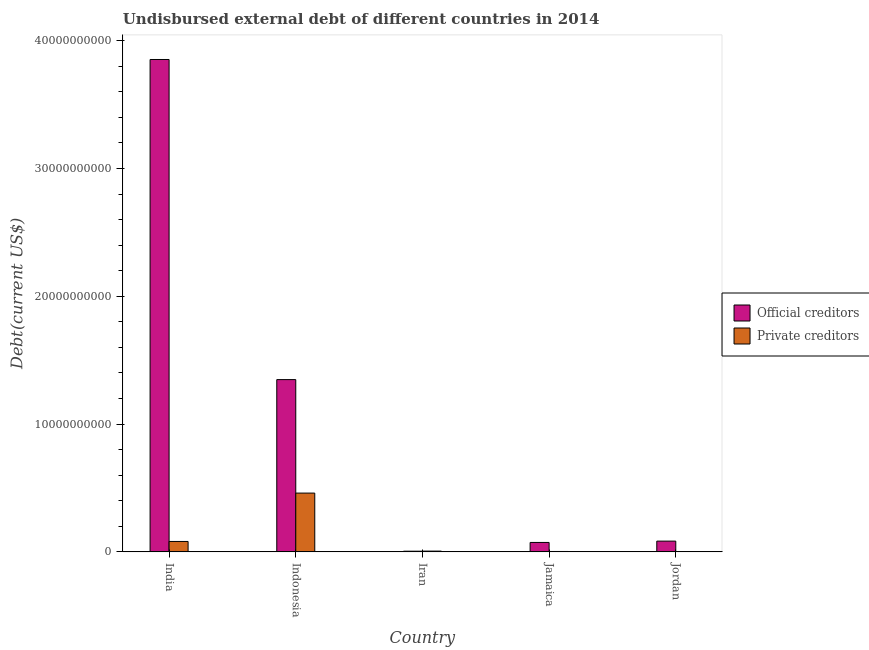How many different coloured bars are there?
Offer a terse response. 2. How many groups of bars are there?
Offer a very short reply. 5. Are the number of bars on each tick of the X-axis equal?
Keep it short and to the point. Yes. How many bars are there on the 2nd tick from the left?
Provide a succinct answer. 2. How many bars are there on the 2nd tick from the right?
Provide a succinct answer. 2. What is the label of the 4th group of bars from the left?
Keep it short and to the point. Jamaica. What is the undisbursed external debt of official creditors in Jamaica?
Provide a short and direct response. 7.37e+08. Across all countries, what is the maximum undisbursed external debt of private creditors?
Your response must be concise. 4.60e+09. Across all countries, what is the minimum undisbursed external debt of private creditors?
Your answer should be compact. 9.01e+06. In which country was the undisbursed external debt of private creditors minimum?
Provide a succinct answer. Jordan. What is the total undisbursed external debt of private creditors in the graph?
Offer a very short reply. 5.51e+09. What is the difference between the undisbursed external debt of official creditors in India and that in Iran?
Offer a very short reply. 3.85e+1. What is the difference between the undisbursed external debt of official creditors in Indonesia and the undisbursed external debt of private creditors in Jordan?
Make the answer very short. 1.35e+1. What is the average undisbursed external debt of official creditors per country?
Your answer should be compact. 1.07e+1. What is the difference between the undisbursed external debt of official creditors and undisbursed external debt of private creditors in India?
Your answer should be very brief. 3.77e+1. In how many countries, is the undisbursed external debt of official creditors greater than 28000000000 US$?
Provide a succinct answer. 1. What is the ratio of the undisbursed external debt of private creditors in India to that in Jordan?
Offer a terse response. 90.35. Is the undisbursed external debt of private creditors in India less than that in Indonesia?
Keep it short and to the point. Yes. Is the difference between the undisbursed external debt of private creditors in Jamaica and Jordan greater than the difference between the undisbursed external debt of official creditors in Jamaica and Jordan?
Provide a short and direct response. Yes. What is the difference between the highest and the second highest undisbursed external debt of official creditors?
Give a very brief answer. 2.50e+1. What is the difference between the highest and the lowest undisbursed external debt of official creditors?
Make the answer very short. 3.85e+1. In how many countries, is the undisbursed external debt of official creditors greater than the average undisbursed external debt of official creditors taken over all countries?
Provide a short and direct response. 2. What does the 2nd bar from the left in Iran represents?
Your response must be concise. Private creditors. What does the 2nd bar from the right in Indonesia represents?
Your answer should be compact. Official creditors. How many bars are there?
Your answer should be very brief. 10. Are all the bars in the graph horizontal?
Give a very brief answer. No. How many countries are there in the graph?
Offer a terse response. 5. Where does the legend appear in the graph?
Provide a succinct answer. Center right. How many legend labels are there?
Your response must be concise. 2. How are the legend labels stacked?
Make the answer very short. Vertical. What is the title of the graph?
Give a very brief answer. Undisbursed external debt of different countries in 2014. Does "Investment in Transport" appear as one of the legend labels in the graph?
Keep it short and to the point. No. What is the label or title of the Y-axis?
Offer a terse response. Debt(current US$). What is the Debt(current US$) of Official creditors in India?
Give a very brief answer. 3.85e+1. What is the Debt(current US$) of Private creditors in India?
Provide a short and direct response. 8.14e+08. What is the Debt(current US$) of Official creditors in Indonesia?
Give a very brief answer. 1.35e+1. What is the Debt(current US$) in Private creditors in Indonesia?
Give a very brief answer. 4.60e+09. What is the Debt(current US$) of Official creditors in Iran?
Offer a very short reply. 5.37e+07. What is the Debt(current US$) in Private creditors in Iran?
Your response must be concise. 6.08e+07. What is the Debt(current US$) in Official creditors in Jamaica?
Provide a succinct answer. 7.37e+08. What is the Debt(current US$) in Private creditors in Jamaica?
Provide a succinct answer. 3.10e+07. What is the Debt(current US$) of Official creditors in Jordan?
Provide a short and direct response. 8.41e+08. What is the Debt(current US$) in Private creditors in Jordan?
Offer a very short reply. 9.01e+06. Across all countries, what is the maximum Debt(current US$) in Official creditors?
Ensure brevity in your answer.  3.85e+1. Across all countries, what is the maximum Debt(current US$) in Private creditors?
Offer a very short reply. 4.60e+09. Across all countries, what is the minimum Debt(current US$) in Official creditors?
Ensure brevity in your answer.  5.37e+07. Across all countries, what is the minimum Debt(current US$) in Private creditors?
Your response must be concise. 9.01e+06. What is the total Debt(current US$) in Official creditors in the graph?
Make the answer very short. 5.36e+1. What is the total Debt(current US$) of Private creditors in the graph?
Your response must be concise. 5.51e+09. What is the difference between the Debt(current US$) of Official creditors in India and that in Indonesia?
Offer a terse response. 2.50e+1. What is the difference between the Debt(current US$) in Private creditors in India and that in Indonesia?
Provide a succinct answer. -3.79e+09. What is the difference between the Debt(current US$) of Official creditors in India and that in Iran?
Provide a short and direct response. 3.85e+1. What is the difference between the Debt(current US$) in Private creditors in India and that in Iran?
Make the answer very short. 7.54e+08. What is the difference between the Debt(current US$) in Official creditors in India and that in Jamaica?
Make the answer very short. 3.78e+1. What is the difference between the Debt(current US$) in Private creditors in India and that in Jamaica?
Your answer should be very brief. 7.83e+08. What is the difference between the Debt(current US$) in Official creditors in India and that in Jordan?
Make the answer very short. 3.77e+1. What is the difference between the Debt(current US$) in Private creditors in India and that in Jordan?
Give a very brief answer. 8.05e+08. What is the difference between the Debt(current US$) in Official creditors in Indonesia and that in Iran?
Make the answer very short. 1.34e+1. What is the difference between the Debt(current US$) of Private creditors in Indonesia and that in Iran?
Provide a short and direct response. 4.54e+09. What is the difference between the Debt(current US$) of Official creditors in Indonesia and that in Jamaica?
Provide a succinct answer. 1.27e+1. What is the difference between the Debt(current US$) of Private creditors in Indonesia and that in Jamaica?
Provide a short and direct response. 4.57e+09. What is the difference between the Debt(current US$) in Official creditors in Indonesia and that in Jordan?
Make the answer very short. 1.26e+1. What is the difference between the Debt(current US$) of Private creditors in Indonesia and that in Jordan?
Your response must be concise. 4.59e+09. What is the difference between the Debt(current US$) in Official creditors in Iran and that in Jamaica?
Make the answer very short. -6.84e+08. What is the difference between the Debt(current US$) of Private creditors in Iran and that in Jamaica?
Offer a terse response. 2.99e+07. What is the difference between the Debt(current US$) of Official creditors in Iran and that in Jordan?
Give a very brief answer. -7.87e+08. What is the difference between the Debt(current US$) in Private creditors in Iran and that in Jordan?
Keep it short and to the point. 5.18e+07. What is the difference between the Debt(current US$) in Official creditors in Jamaica and that in Jordan?
Your answer should be very brief. -1.04e+08. What is the difference between the Debt(current US$) of Private creditors in Jamaica and that in Jordan?
Keep it short and to the point. 2.19e+07. What is the difference between the Debt(current US$) of Official creditors in India and the Debt(current US$) of Private creditors in Indonesia?
Provide a succinct answer. 3.39e+1. What is the difference between the Debt(current US$) of Official creditors in India and the Debt(current US$) of Private creditors in Iran?
Your answer should be very brief. 3.85e+1. What is the difference between the Debt(current US$) in Official creditors in India and the Debt(current US$) in Private creditors in Jamaica?
Your answer should be very brief. 3.85e+1. What is the difference between the Debt(current US$) of Official creditors in India and the Debt(current US$) of Private creditors in Jordan?
Offer a terse response. 3.85e+1. What is the difference between the Debt(current US$) of Official creditors in Indonesia and the Debt(current US$) of Private creditors in Iran?
Offer a terse response. 1.34e+1. What is the difference between the Debt(current US$) in Official creditors in Indonesia and the Debt(current US$) in Private creditors in Jamaica?
Your response must be concise. 1.34e+1. What is the difference between the Debt(current US$) of Official creditors in Indonesia and the Debt(current US$) of Private creditors in Jordan?
Provide a succinct answer. 1.35e+1. What is the difference between the Debt(current US$) in Official creditors in Iran and the Debt(current US$) in Private creditors in Jamaica?
Your answer should be very brief. 2.27e+07. What is the difference between the Debt(current US$) in Official creditors in Iran and the Debt(current US$) in Private creditors in Jordan?
Offer a terse response. 4.46e+07. What is the difference between the Debt(current US$) of Official creditors in Jamaica and the Debt(current US$) of Private creditors in Jordan?
Your answer should be very brief. 7.28e+08. What is the average Debt(current US$) in Official creditors per country?
Keep it short and to the point. 1.07e+1. What is the average Debt(current US$) of Private creditors per country?
Offer a very short reply. 1.10e+09. What is the difference between the Debt(current US$) in Official creditors and Debt(current US$) in Private creditors in India?
Provide a short and direct response. 3.77e+1. What is the difference between the Debt(current US$) in Official creditors and Debt(current US$) in Private creditors in Indonesia?
Your response must be concise. 8.88e+09. What is the difference between the Debt(current US$) of Official creditors and Debt(current US$) of Private creditors in Iran?
Your answer should be very brief. -7.14e+06. What is the difference between the Debt(current US$) of Official creditors and Debt(current US$) of Private creditors in Jamaica?
Give a very brief answer. 7.06e+08. What is the difference between the Debt(current US$) in Official creditors and Debt(current US$) in Private creditors in Jordan?
Ensure brevity in your answer.  8.32e+08. What is the ratio of the Debt(current US$) in Official creditors in India to that in Indonesia?
Offer a terse response. 2.86. What is the ratio of the Debt(current US$) of Private creditors in India to that in Indonesia?
Give a very brief answer. 0.18. What is the ratio of the Debt(current US$) of Official creditors in India to that in Iran?
Provide a succinct answer. 717.95. What is the ratio of the Debt(current US$) in Private creditors in India to that in Iran?
Ensure brevity in your answer.  13.39. What is the ratio of the Debt(current US$) in Official creditors in India to that in Jamaica?
Offer a terse response. 52.25. What is the ratio of the Debt(current US$) of Private creditors in India to that in Jamaica?
Ensure brevity in your answer.  26.31. What is the ratio of the Debt(current US$) of Official creditors in India to that in Jordan?
Keep it short and to the point. 45.8. What is the ratio of the Debt(current US$) in Private creditors in India to that in Jordan?
Your response must be concise. 90.34. What is the ratio of the Debt(current US$) of Official creditors in Indonesia to that in Iran?
Make the answer very short. 251.19. What is the ratio of the Debt(current US$) in Private creditors in Indonesia to that in Iran?
Provide a short and direct response. 75.65. What is the ratio of the Debt(current US$) of Official creditors in Indonesia to that in Jamaica?
Provide a short and direct response. 18.28. What is the ratio of the Debt(current US$) in Private creditors in Indonesia to that in Jamaica?
Provide a short and direct response. 148.6. What is the ratio of the Debt(current US$) of Official creditors in Indonesia to that in Jordan?
Your answer should be very brief. 16.03. What is the ratio of the Debt(current US$) of Private creditors in Indonesia to that in Jordan?
Offer a terse response. 510.29. What is the ratio of the Debt(current US$) of Official creditors in Iran to that in Jamaica?
Keep it short and to the point. 0.07. What is the ratio of the Debt(current US$) of Private creditors in Iran to that in Jamaica?
Your answer should be very brief. 1.96. What is the ratio of the Debt(current US$) in Official creditors in Iran to that in Jordan?
Ensure brevity in your answer.  0.06. What is the ratio of the Debt(current US$) in Private creditors in Iran to that in Jordan?
Offer a terse response. 6.75. What is the ratio of the Debt(current US$) of Official creditors in Jamaica to that in Jordan?
Give a very brief answer. 0.88. What is the ratio of the Debt(current US$) of Private creditors in Jamaica to that in Jordan?
Your answer should be very brief. 3.43. What is the difference between the highest and the second highest Debt(current US$) of Official creditors?
Offer a very short reply. 2.50e+1. What is the difference between the highest and the second highest Debt(current US$) of Private creditors?
Your answer should be compact. 3.79e+09. What is the difference between the highest and the lowest Debt(current US$) in Official creditors?
Your response must be concise. 3.85e+1. What is the difference between the highest and the lowest Debt(current US$) of Private creditors?
Make the answer very short. 4.59e+09. 